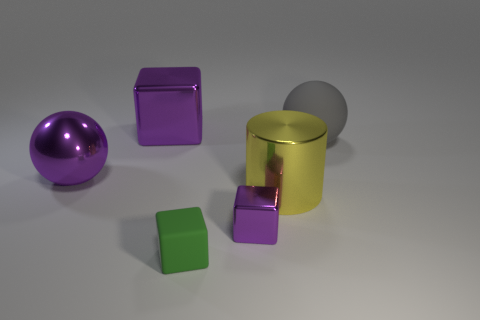There is another small object that is the same shape as the tiny green matte thing; what is its color?
Make the answer very short. Purple. Is there anything else that has the same shape as the small purple metal object?
Make the answer very short. Yes. Are there an equal number of tiny green things behind the large yellow metal cylinder and small purple shiny cubes?
Your response must be concise. No. Are there any spheres right of the small green object?
Your response must be concise. Yes. What is the size of the rubber thing that is behind the purple thing that is on the right side of the purple cube behind the tiny metallic object?
Offer a terse response. Large. Does the metal thing that is behind the big metallic ball have the same shape as the tiny object that is on the right side of the small rubber object?
Offer a terse response. Yes. The purple metallic thing that is the same shape as the big matte thing is what size?
Provide a short and direct response. Large. How many large purple things are made of the same material as the big purple block?
Make the answer very short. 1. What is the large block made of?
Your response must be concise. Metal. The large purple shiny thing that is behind the big ball that is on the right side of the purple ball is what shape?
Offer a terse response. Cube. 